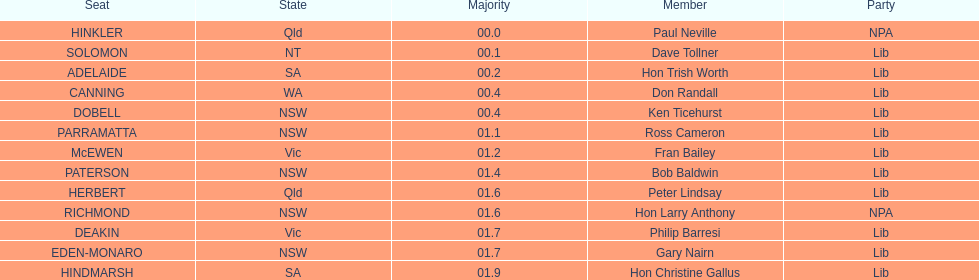Who is listed before don randall? Hon Trish Worth. 